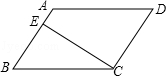Explain how you would calculate the area of the parallelogram shown in the image. To calculate the area of the parallelogram, you would start by identifying the base and the height. In this image, if we consider AB as the base, then the segment CE can be used as the height, as it is drawn perpendicular to AB. The area can then be calculated using the formula: Area = base x height = AB x CE. 